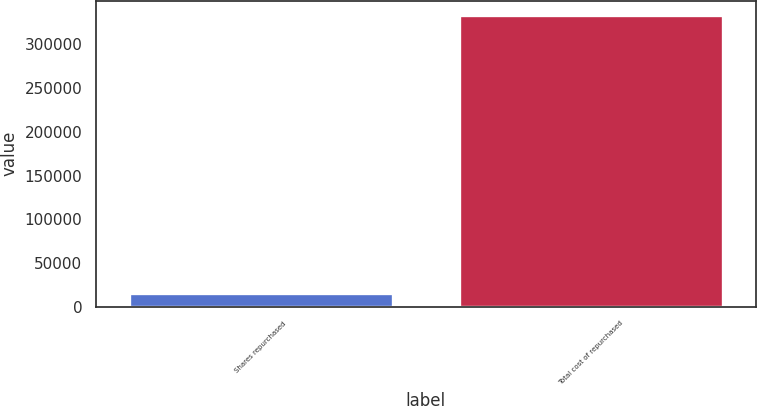Convert chart to OTSL. <chart><loc_0><loc_0><loc_500><loc_500><bar_chart><fcel>Shares repurchased<fcel>Total cost of repurchased<nl><fcel>16255<fcel>333189<nl></chart> 